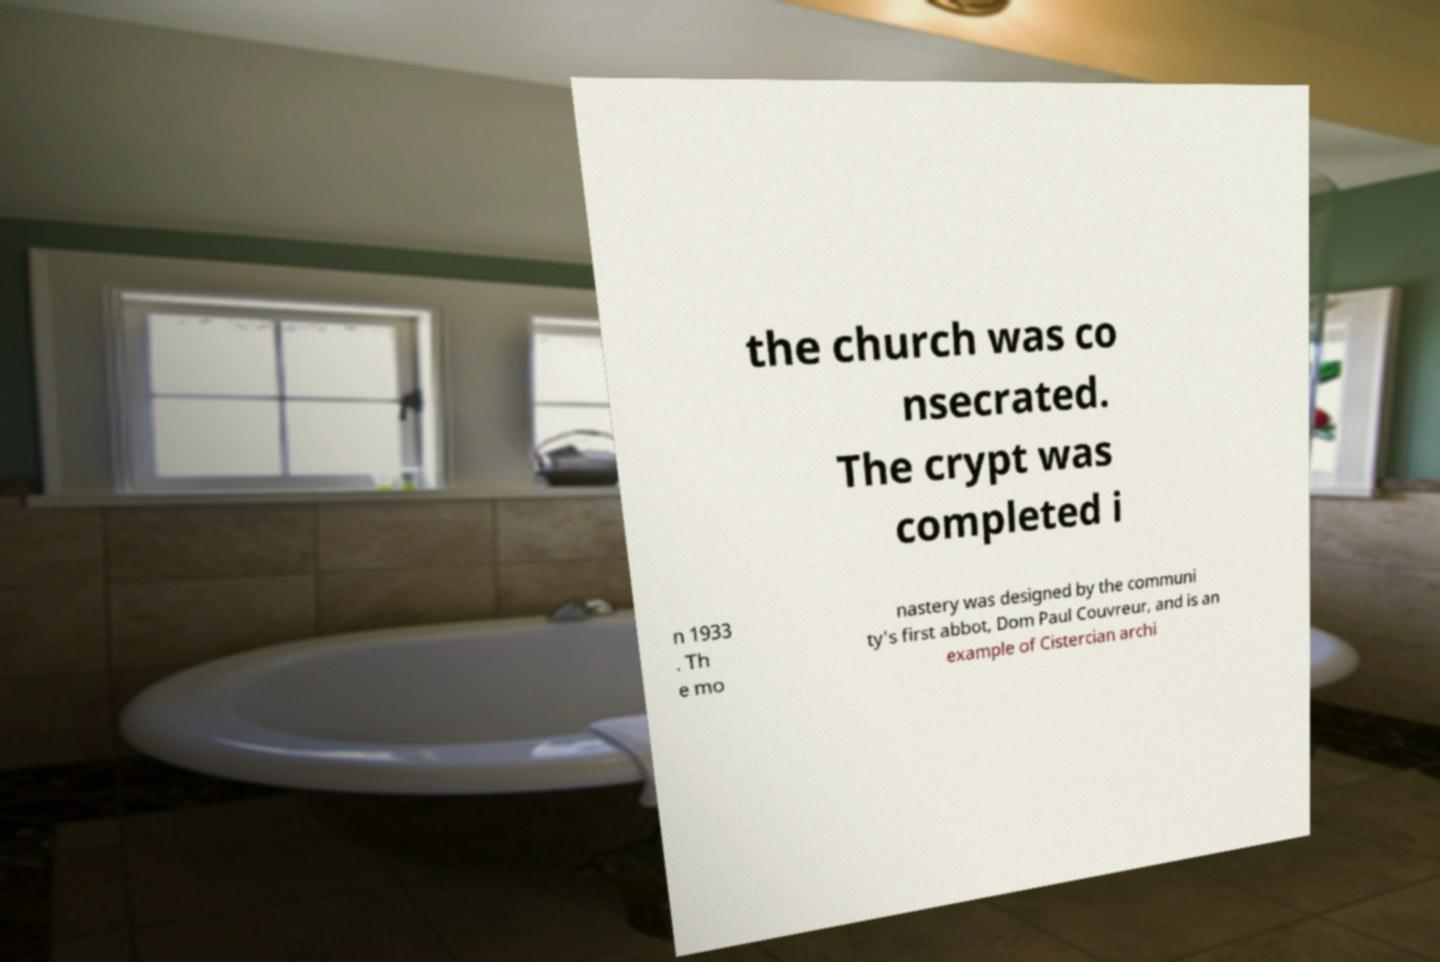Please identify and transcribe the text found in this image. the church was co nsecrated. The crypt was completed i n 1933 . Th e mo nastery was designed by the communi ty's first abbot, Dom Paul Couvreur, and is an example of Cistercian archi 